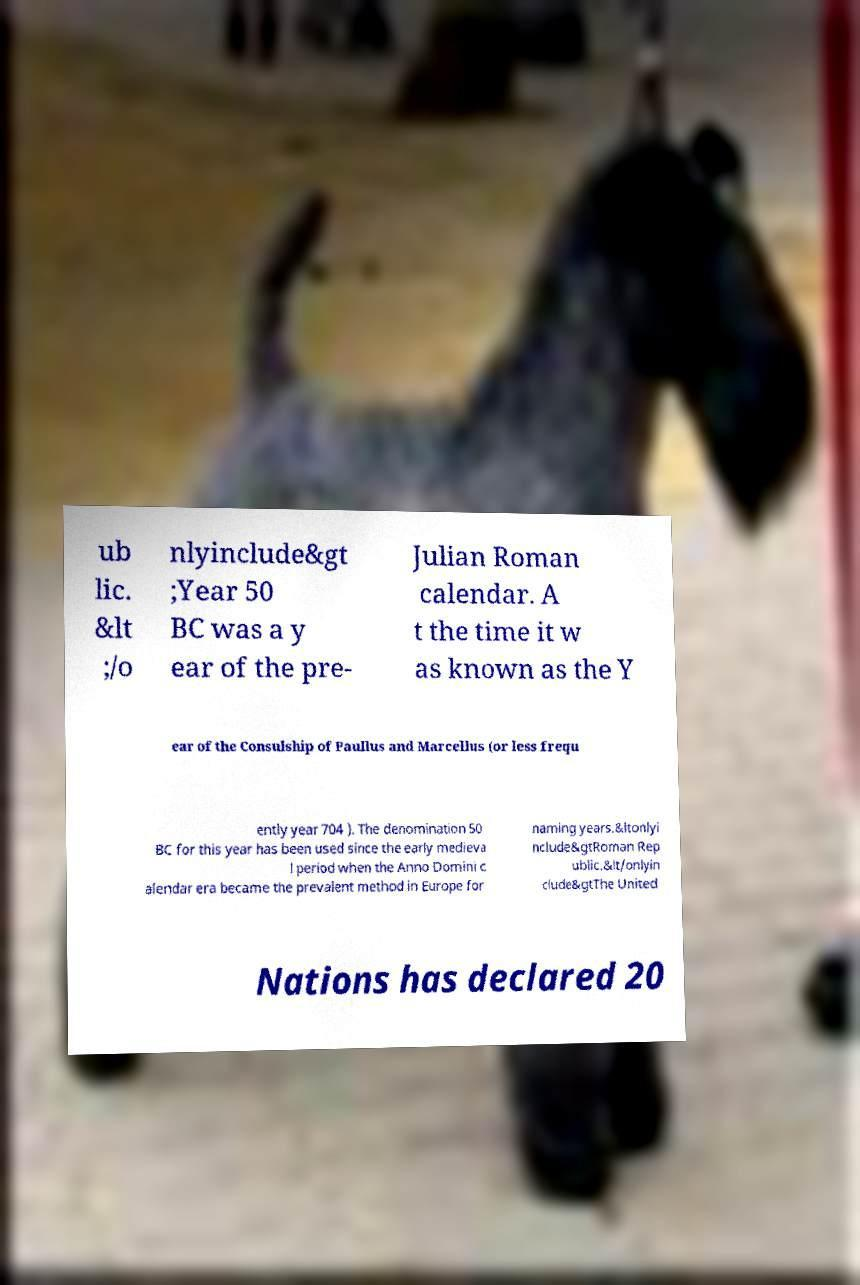For documentation purposes, I need the text within this image transcribed. Could you provide that? ub lic. &lt ;/o nlyinclude&gt ;Year 50 BC was a y ear of the pre- Julian Roman calendar. A t the time it w as known as the Y ear of the Consulship of Paullus and Marcellus (or less frequ ently year 704 ). The denomination 50 BC for this year has been used since the early medieva l period when the Anno Domini c alendar era became the prevalent method in Europe for naming years.&ltonlyi nclude&gtRoman Rep ublic.&lt/onlyin clude&gtThe United Nations has declared 20 